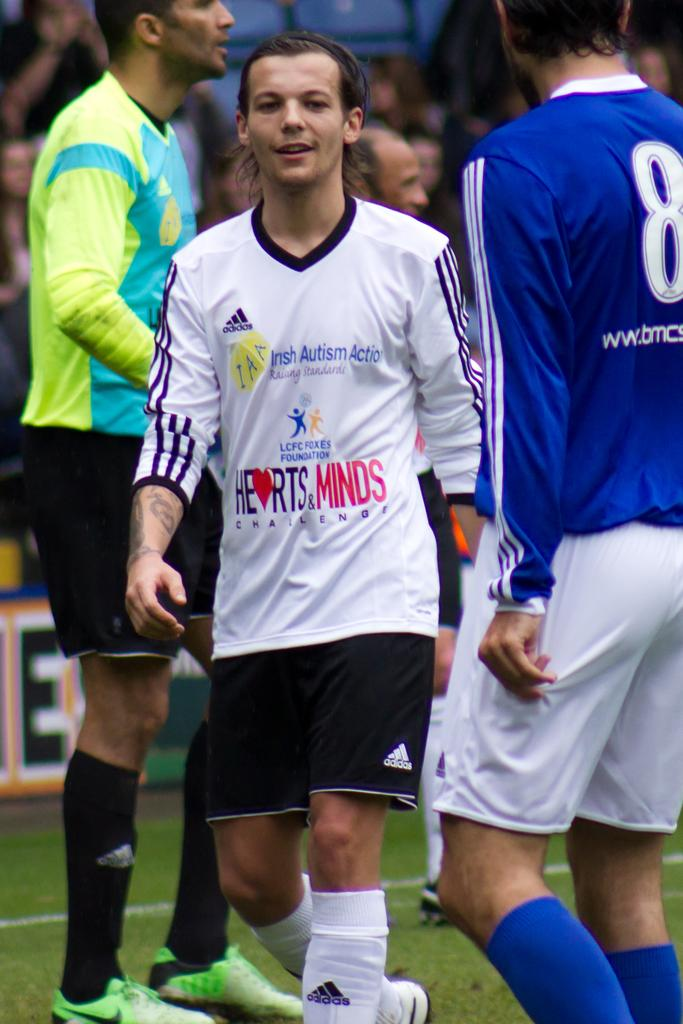Provide a one-sentence caption for the provided image. A man is supporting Irish Autism Action by playing soccer with others. 